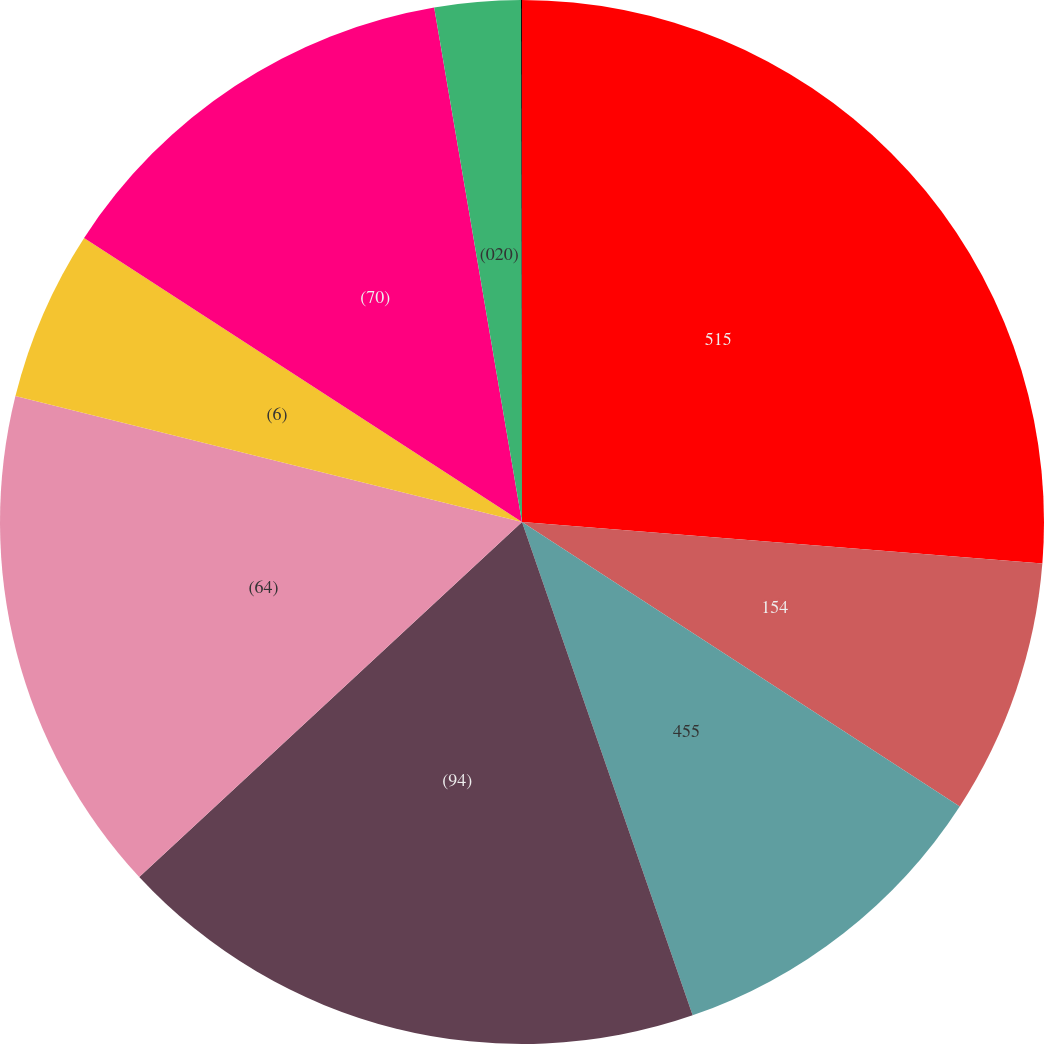Convert chart to OTSL. <chart><loc_0><loc_0><loc_500><loc_500><pie_chart><fcel>515<fcel>154<fcel>455<fcel>(94)<fcel>(64)<fcel>(6)<fcel>(70)<fcel>(020)<fcel>(022)<nl><fcel>26.27%<fcel>7.9%<fcel>10.53%<fcel>18.4%<fcel>15.78%<fcel>5.28%<fcel>13.15%<fcel>2.66%<fcel>0.03%<nl></chart> 